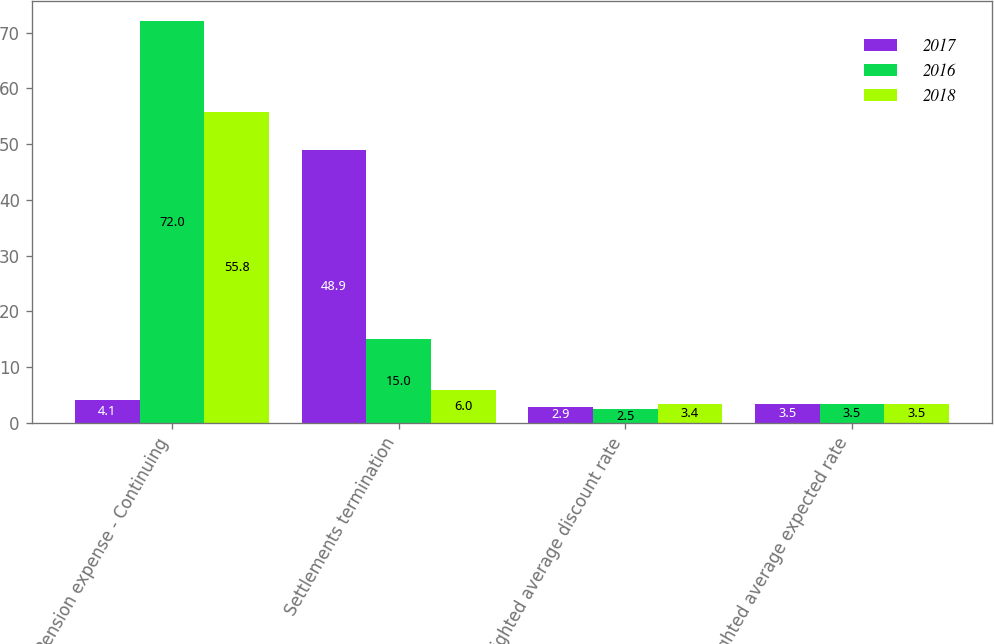Convert chart. <chart><loc_0><loc_0><loc_500><loc_500><stacked_bar_chart><ecel><fcel>Pension expense - Continuing<fcel>Settlements termination<fcel>Weighted average discount rate<fcel>Weighted average expected rate<nl><fcel>2017<fcel>4.1<fcel>48.9<fcel>2.9<fcel>3.5<nl><fcel>2016<fcel>72<fcel>15<fcel>2.5<fcel>3.5<nl><fcel>2018<fcel>55.8<fcel>6<fcel>3.4<fcel>3.5<nl></chart> 